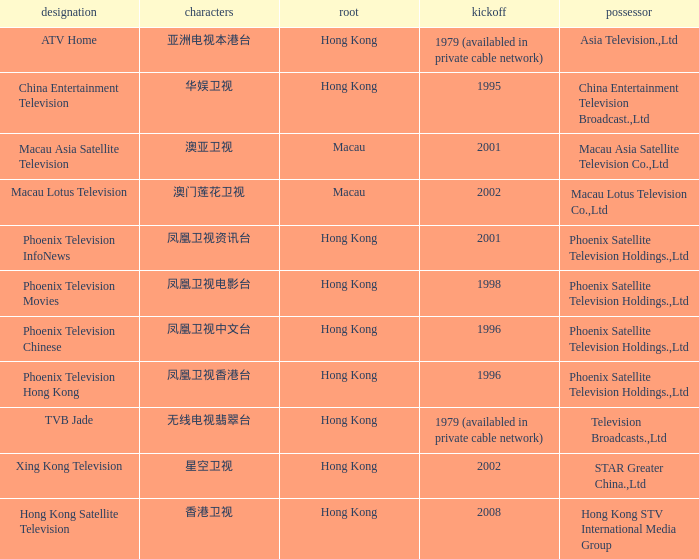Which company launched in 1996 and has a Hanzi of 凤凰卫视中文台? Phoenix Television Chinese. 